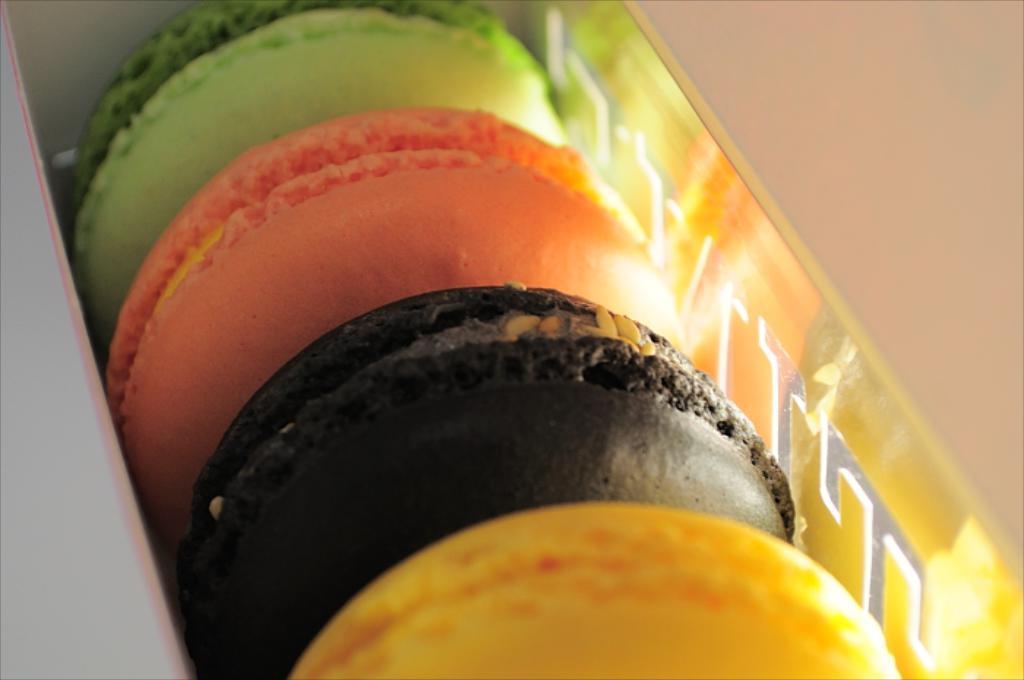Describe this image in one or two sentences. In this image there are biscuits. There is the cream in between the biscuits. The biscuits are in different colors. They are placed in a box. 